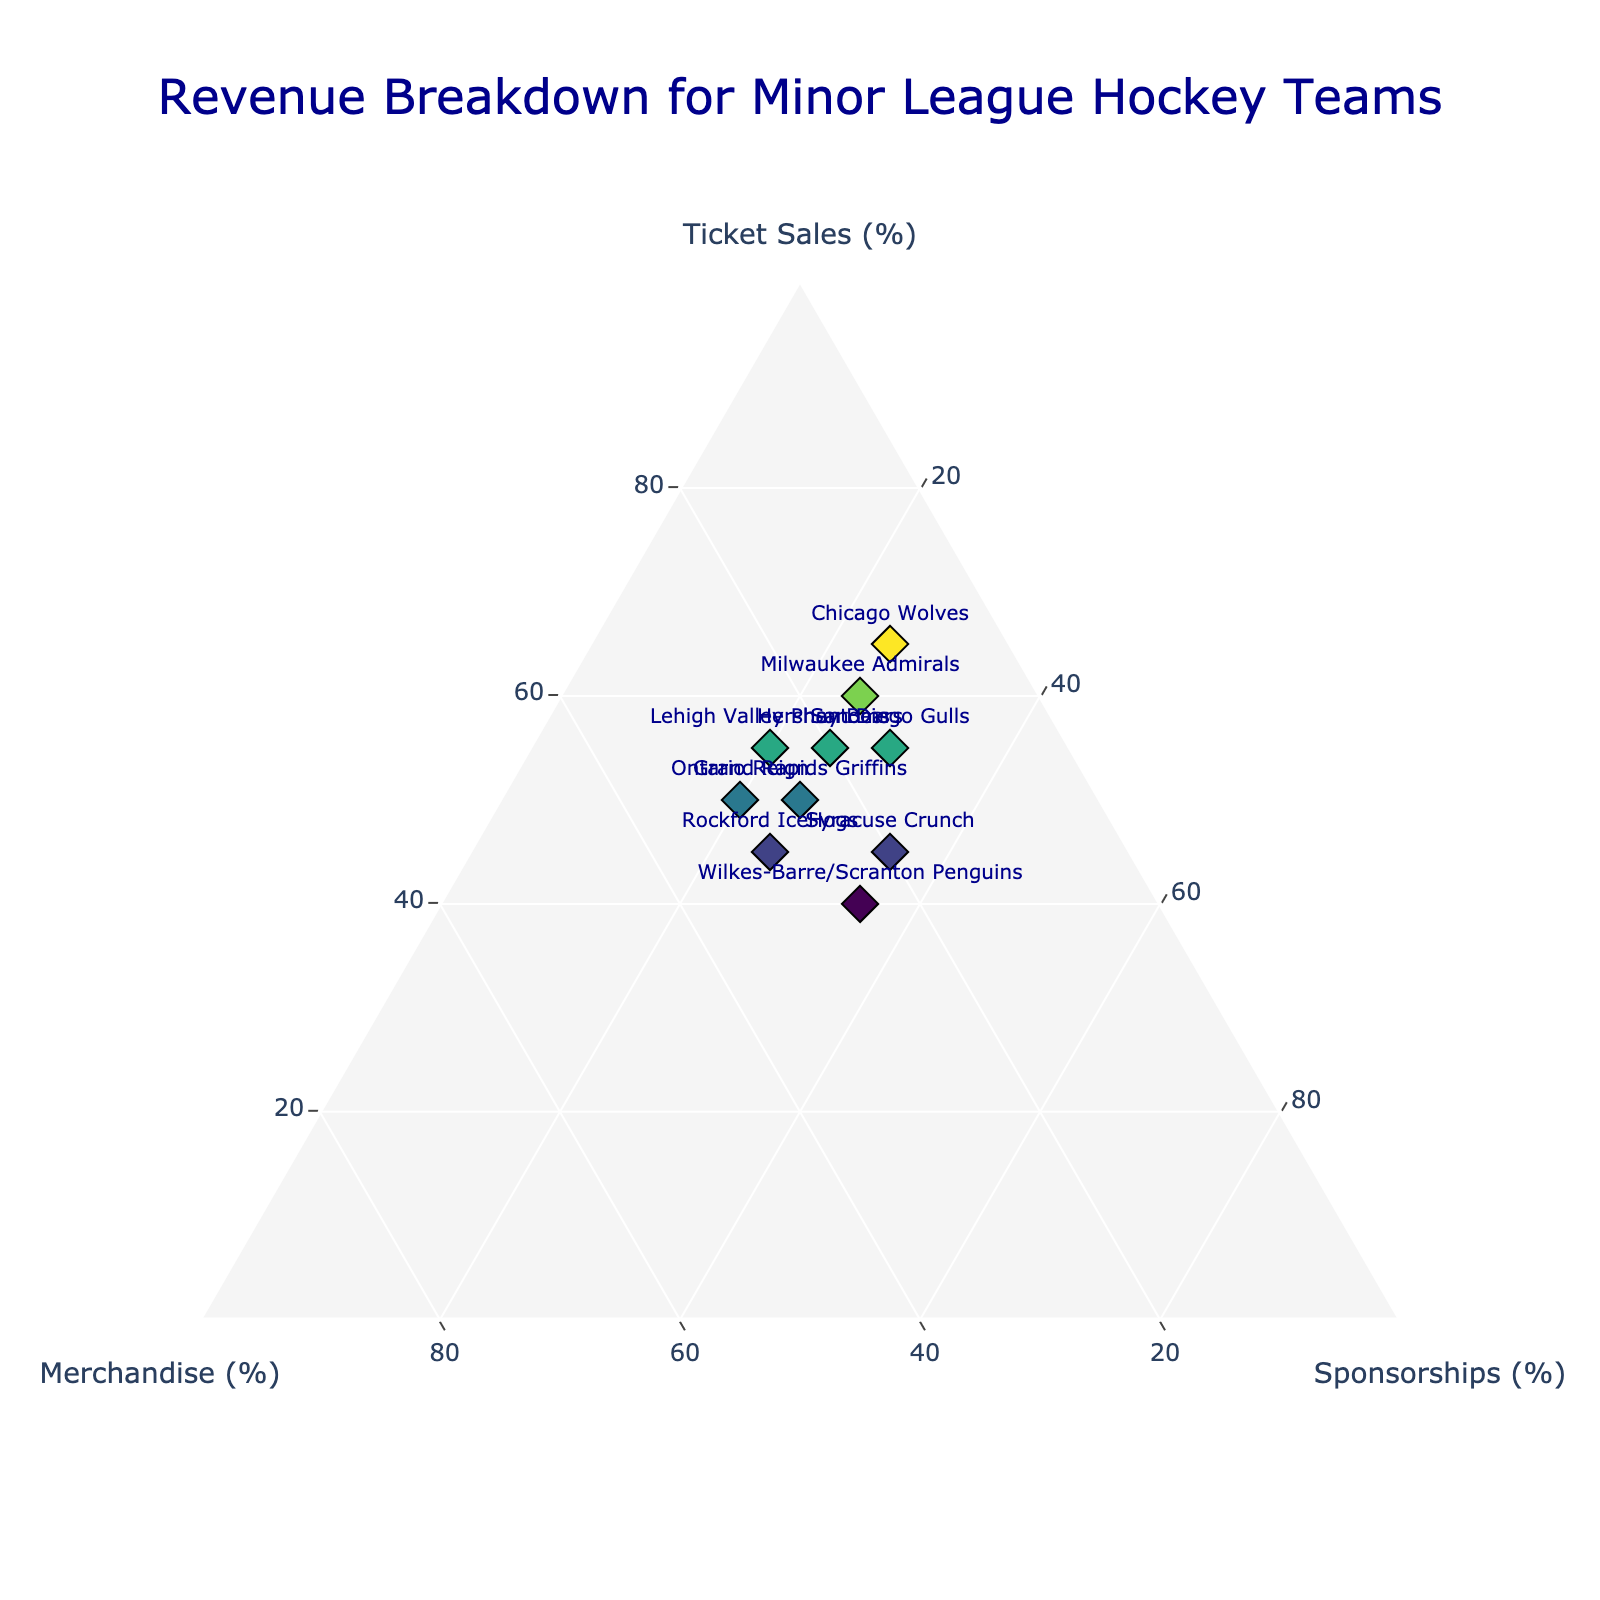What's the title of the ternary plot? Look at the top center of the plot where the title is typically displayed. The title conveys the main topic or purpose of the plot.
Answer: "Revenue Breakdown for Minor League Hockey Teams" How many teams are represented in the plot? Count the number of unique data points (markers) in the plot. Each marker typically represents one team.
Answer: 10 Which team has the highest revenue from ticket sales? Look for the data point closest to the "Ticket Sales" axis. The value indicating the highest percentage on this axis belongs to the team you're looking for.
Answer: Chicago Wolves What's the relationship between the sponsorship revenue of Hershey Bears and Syracuse Crunch? Compare the positions of Hershey Bears and Syracuse Crunch along the "Sponsorships" axis to see which is higher or if they are equal.
Answer: Syracuse Crunch has a higher sponsorship revenue than Hershey Bears Which team has equal contributions from ticket sales, merchandise, and sponsorships? Look for a data point that is positioned approximately where all three axes intersect equally, indicating a balanced contribution.
Answer: None What's the total percentage of revenue for the Wilkes-Barre/Scranton Penguins excluding ticket sales? Look at the percentages for merchandise and sponsorships for the Wilkes-Barre/Scranton Penguins and sum them up (25% + 35%).
Answer: 60% What's the average percentage of ticket sales across all teams? Sum all ticket sales percentages and divide by the number of teams. Calculation: (60 + 55 + 50 + 45 + 55 + 65 + 50 + 40 + 45 + 55) / 10 = 52%
Answer: 52% Which team has the lowest percentage of merchandise revenue? Find the data point closest to the bottom (near the "Merchandise" axis) to see which team has the lowest value.
Answer: Chicago Wolves What's the exact percentage breakdown for Rockford IceHogs? Hover over or examine the data point for Rockford IceHogs to see the exact values of ticket sales, merchandise, and sponsorships.
Answer: Ticket Sales: 45%, Merchandise: 30%, Sponsorships: 25% How does Lehigh Valley Phantoms' merchandise revenue compare with Ontario Reign's? Compare the positions of Lehigh Valley Phantoms and Ontario Reign on the "Merchandise" axis to determine which segment is greater.
Answer: Ontario Reign has higher merchandise revenue than Lehigh Valley Phantoms 